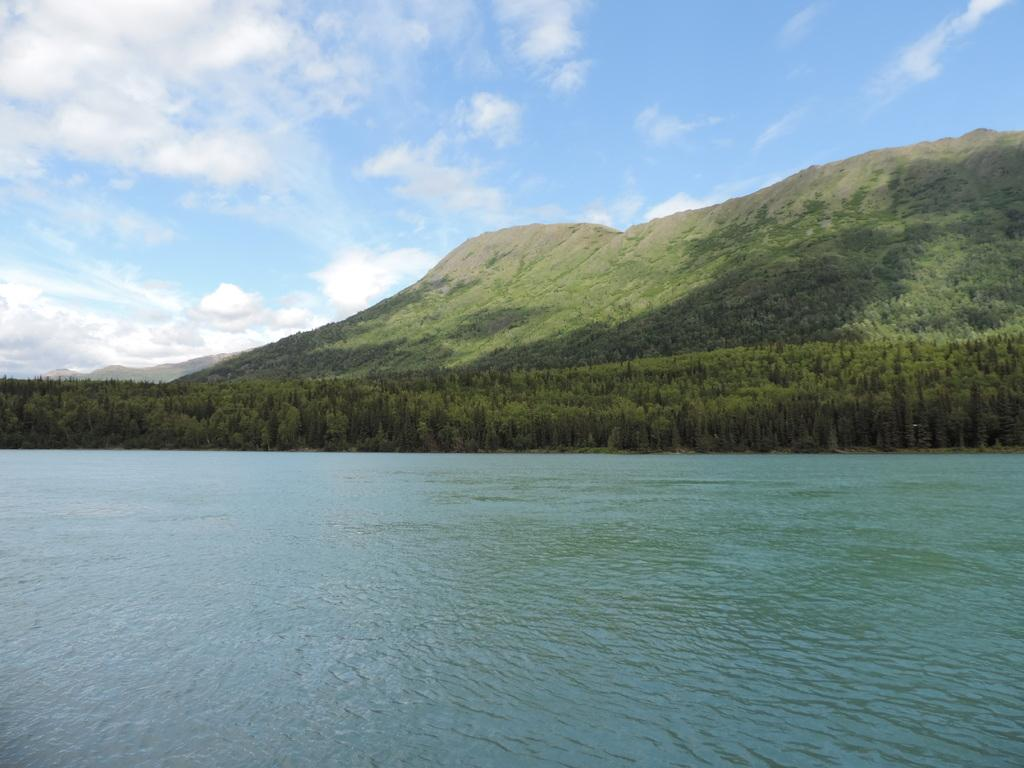What is at the bottom of the image? There is water at the bottom of the image. What can be seen behind the water? There are trees behind the water. What is located on the hill in the image? There is a hill with trees in the image. What is visible at the top of the image? The sky is visible at the top of the image. What can be observed in the sky? Clouds are present in the sky. How many feet are visible in the image? There are no feet present in the image. What story is being told in the image? The image does not depict a story; it is a scene of water, trees, a hill, and the sky. 